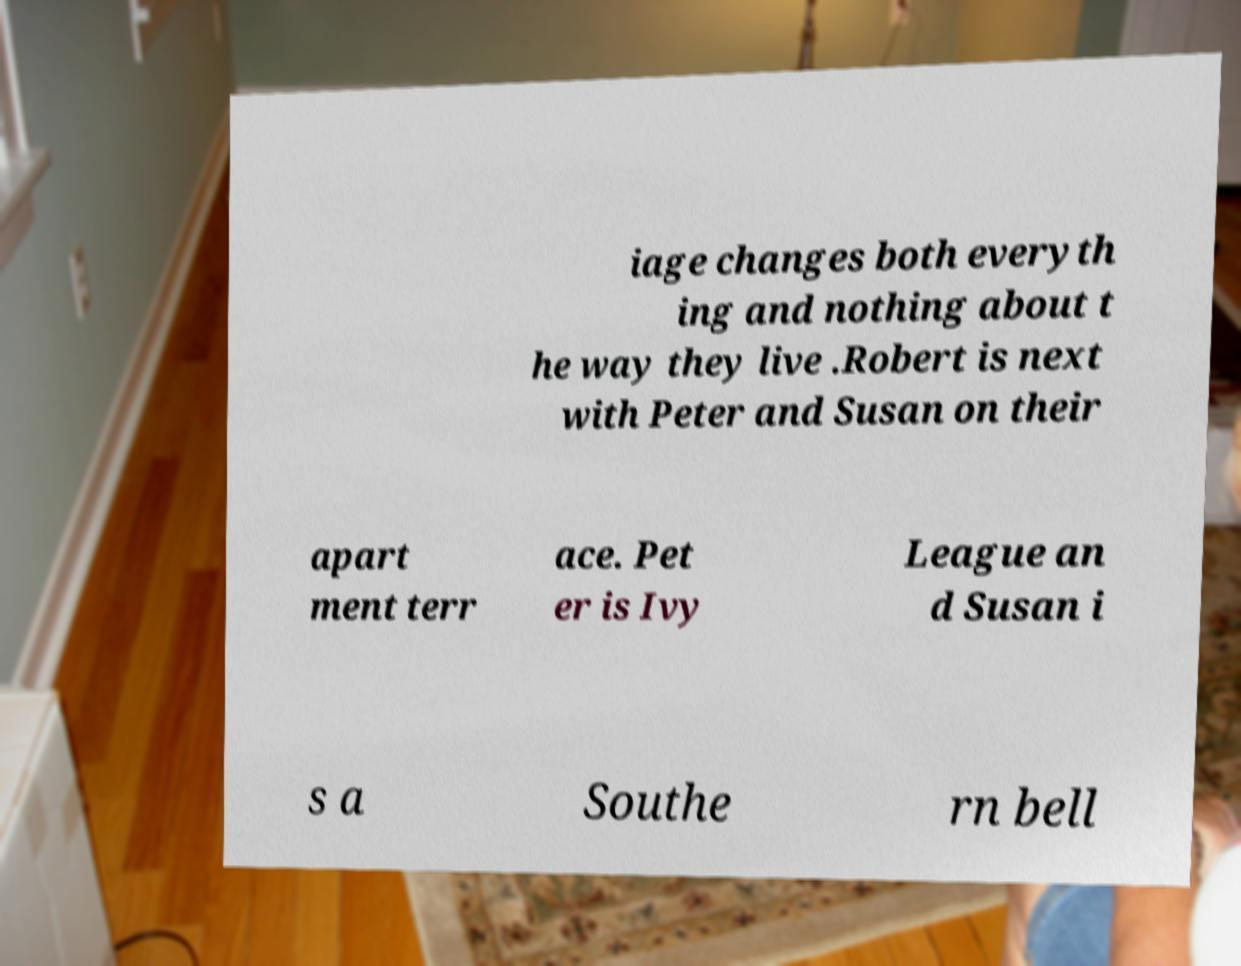Can you read and provide the text displayed in the image?This photo seems to have some interesting text. Can you extract and type it out for me? iage changes both everyth ing and nothing about t he way they live .Robert is next with Peter and Susan on their apart ment terr ace. Pet er is Ivy League an d Susan i s a Southe rn bell 